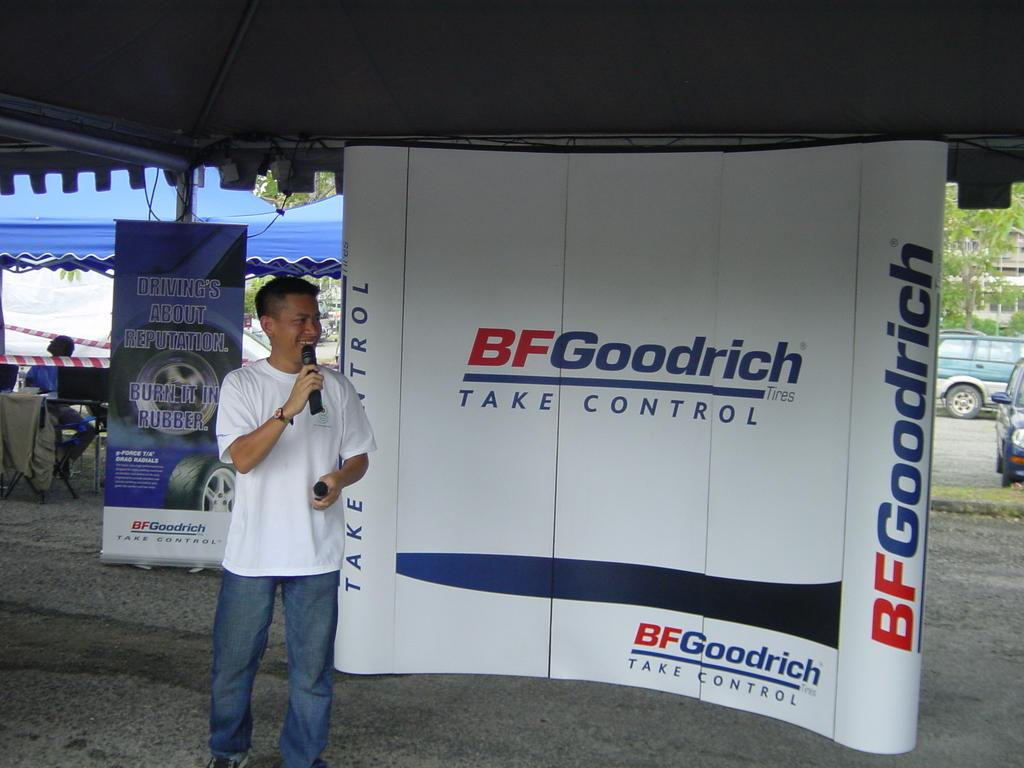What is the person in the center of the image doing? The person is standing in the center of the image and holding a mic. What can be seen in the background of the image? There is an advertisement, tents, at least one person, vehicles, trees, and a building visible in the background. Can you describe the setting of the image? The image appears to be set in an outdoor area with a background that includes various structures and natural elements. How does the person feel about the stream in the image? There is no stream present in the image, so it is not possible to determine how the person feels about it. 